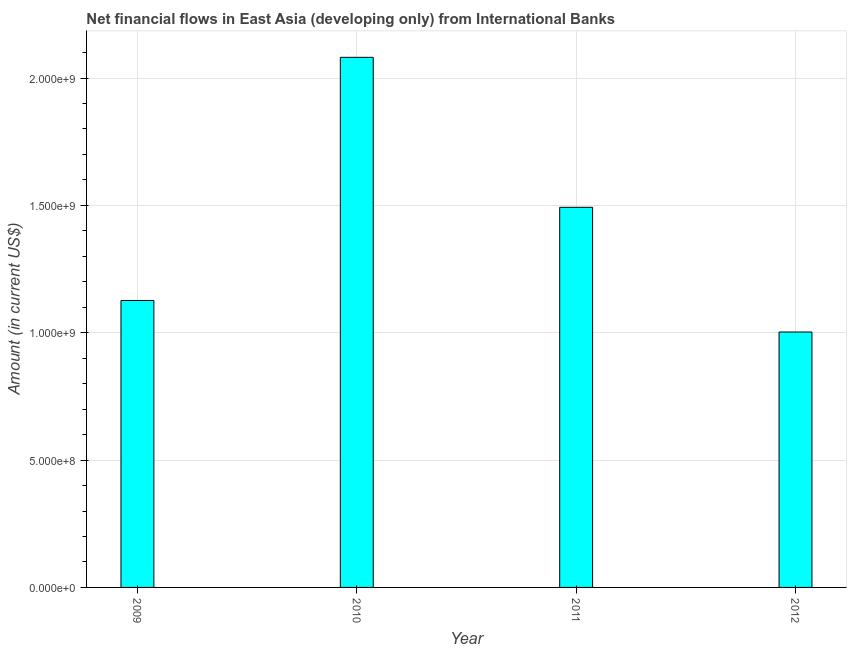Does the graph contain any zero values?
Your answer should be compact. No. What is the title of the graph?
Keep it short and to the point. Net financial flows in East Asia (developing only) from International Banks. What is the net financial flows from ibrd in 2010?
Your answer should be compact. 2.08e+09. Across all years, what is the maximum net financial flows from ibrd?
Keep it short and to the point. 2.08e+09. Across all years, what is the minimum net financial flows from ibrd?
Ensure brevity in your answer.  1.00e+09. What is the sum of the net financial flows from ibrd?
Keep it short and to the point. 5.70e+09. What is the difference between the net financial flows from ibrd in 2009 and 2011?
Offer a very short reply. -3.66e+08. What is the average net financial flows from ibrd per year?
Give a very brief answer. 1.43e+09. What is the median net financial flows from ibrd?
Your answer should be very brief. 1.31e+09. What is the ratio of the net financial flows from ibrd in 2009 to that in 2010?
Your answer should be very brief. 0.54. Is the net financial flows from ibrd in 2009 less than that in 2012?
Ensure brevity in your answer.  No. Is the difference between the net financial flows from ibrd in 2010 and 2011 greater than the difference between any two years?
Provide a succinct answer. No. What is the difference between the highest and the second highest net financial flows from ibrd?
Ensure brevity in your answer.  5.89e+08. Is the sum of the net financial flows from ibrd in 2011 and 2012 greater than the maximum net financial flows from ibrd across all years?
Offer a terse response. Yes. What is the difference between the highest and the lowest net financial flows from ibrd?
Make the answer very short. 1.08e+09. What is the difference between two consecutive major ticks on the Y-axis?
Your answer should be very brief. 5.00e+08. What is the Amount (in current US$) of 2009?
Make the answer very short. 1.13e+09. What is the Amount (in current US$) in 2010?
Offer a terse response. 2.08e+09. What is the Amount (in current US$) of 2011?
Keep it short and to the point. 1.49e+09. What is the Amount (in current US$) of 2012?
Your answer should be compact. 1.00e+09. What is the difference between the Amount (in current US$) in 2009 and 2010?
Ensure brevity in your answer.  -9.55e+08. What is the difference between the Amount (in current US$) in 2009 and 2011?
Make the answer very short. -3.66e+08. What is the difference between the Amount (in current US$) in 2009 and 2012?
Ensure brevity in your answer.  1.24e+08. What is the difference between the Amount (in current US$) in 2010 and 2011?
Your response must be concise. 5.89e+08. What is the difference between the Amount (in current US$) in 2010 and 2012?
Your answer should be very brief. 1.08e+09. What is the difference between the Amount (in current US$) in 2011 and 2012?
Ensure brevity in your answer.  4.90e+08. What is the ratio of the Amount (in current US$) in 2009 to that in 2010?
Make the answer very short. 0.54. What is the ratio of the Amount (in current US$) in 2009 to that in 2011?
Ensure brevity in your answer.  0.76. What is the ratio of the Amount (in current US$) in 2009 to that in 2012?
Offer a terse response. 1.12. What is the ratio of the Amount (in current US$) in 2010 to that in 2011?
Offer a very short reply. 1.4. What is the ratio of the Amount (in current US$) in 2010 to that in 2012?
Your answer should be very brief. 2.08. What is the ratio of the Amount (in current US$) in 2011 to that in 2012?
Provide a succinct answer. 1.49. 